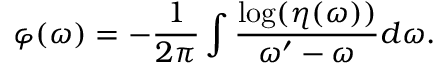Convert formula to latex. <formula><loc_0><loc_0><loc_500><loc_500>\varphi ( \omega ) = - \frac { 1 } { 2 \pi } \int \frac { \log ( \eta ( \omega ) ) } { \omega ^ { \prime } - \omega } d \omega .</formula> 